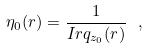<formula> <loc_0><loc_0><loc_500><loc_500>\eta _ { 0 } ( r ) = \frac { 1 } { I r q _ { z _ { 0 } } ( r ) } \ ,</formula> 